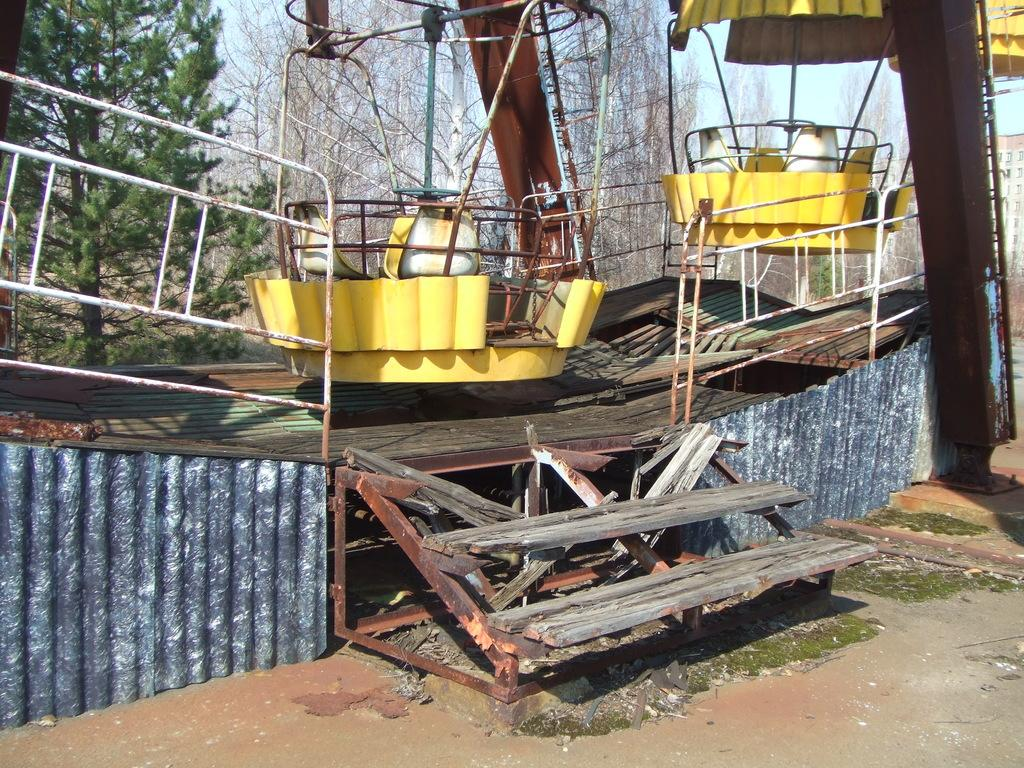What type of attraction is featured in the image? There is a fun ride in the image. What natural elements can be seen in the image? There are trees in the image. What can be seen in the background of the image? The sky is visible in the background of the image. What safety features are present in the image? Railings are present in the image. What architectural feature is visible in the image? There are steps in the image. What object is present that might be used for support or guidance? There is a rod in the image. What type of prison can be seen in the image? There is no prison present in the image; it features a fun ride and other elements. What caption is written on the fun ride in the image? There is no caption visible on the fun ride in the image. 